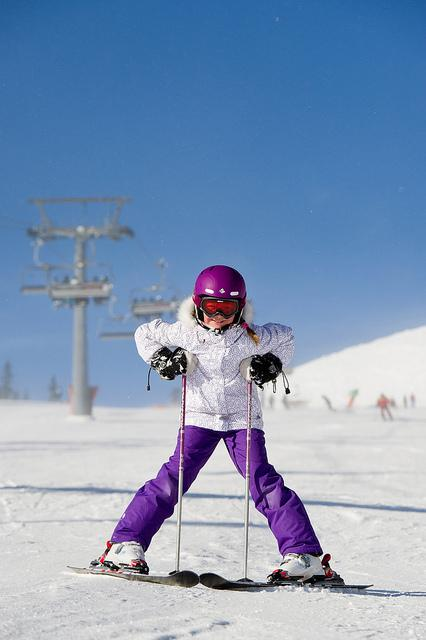What is the girl using the poles to do? balance 